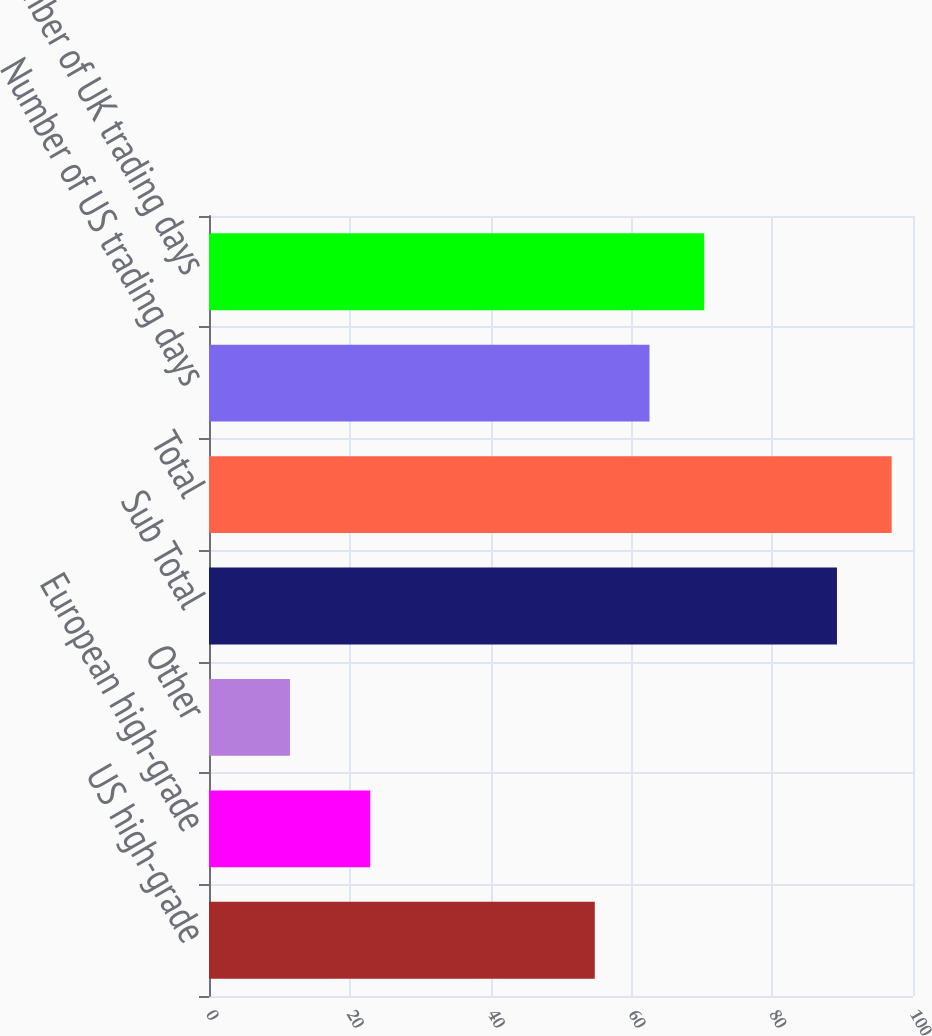<chart> <loc_0><loc_0><loc_500><loc_500><bar_chart><fcel>US high-grade<fcel>European high-grade<fcel>Other<fcel>Sub Total<fcel>Total<fcel>Number of US trading days<fcel>Number of UK trading days<nl><fcel>54.8<fcel>22.9<fcel>11.5<fcel>89.2<fcel>96.97<fcel>62.57<fcel>70.34<nl></chart> 